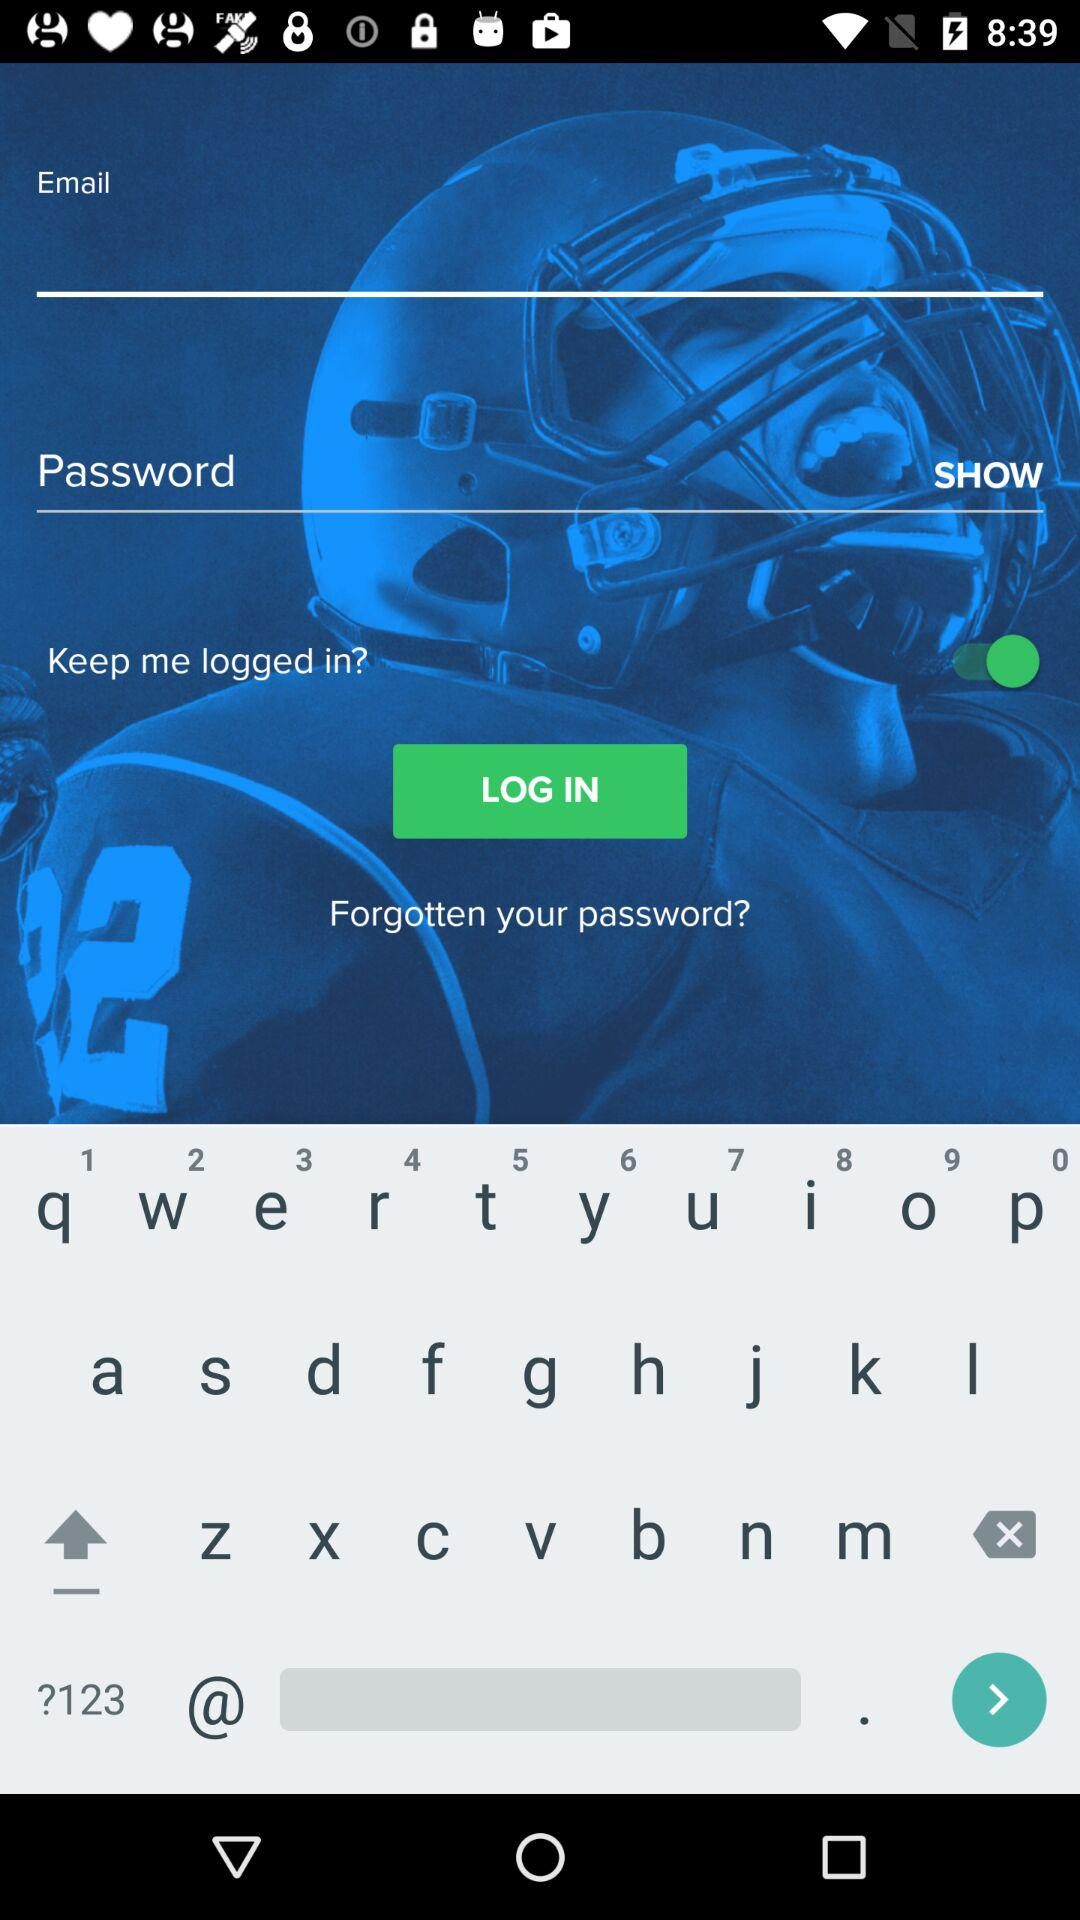What is the app name? The app name is "FANDUEL". 